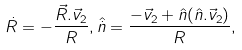Convert formula to latex. <formula><loc_0><loc_0><loc_500><loc_500>\dot { R } = - \frac { \vec { R } . \vec { v } _ { 2 } } { R } , \hat { \dot { n } } = \frac { - \vec { v } _ { 2 } + \hat { n } ( \hat { n } . \vec { v } _ { 2 } ) } { R } ,</formula> 